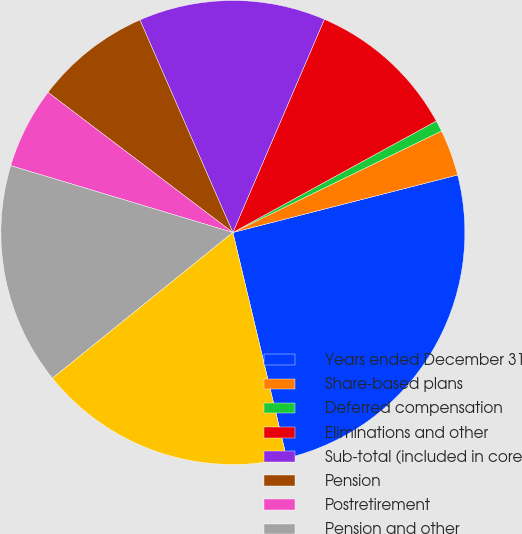Convert chart. <chart><loc_0><loc_0><loc_500><loc_500><pie_chart><fcel>Years ended December 31<fcel>Share-based plans<fcel>Deferred compensation<fcel>Eliminations and other<fcel>Sub-total (included in core<fcel>Pension<fcel>Postretirement<fcel>Pension and other<fcel>Total<nl><fcel>25.27%<fcel>3.22%<fcel>0.77%<fcel>10.57%<fcel>13.02%<fcel>8.12%<fcel>5.67%<fcel>15.47%<fcel>17.92%<nl></chart> 